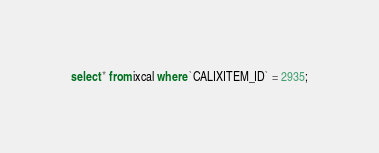<code> <loc_0><loc_0><loc_500><loc_500><_SQL_>select * from ixcal where `CALIXITEM_ID` = 2935;
</code> 